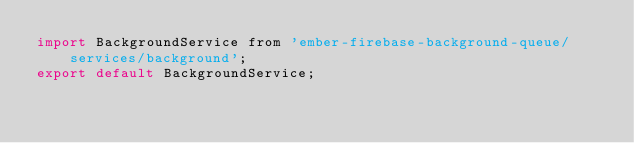Convert code to text. <code><loc_0><loc_0><loc_500><loc_500><_JavaScript_>import BackgroundService from 'ember-firebase-background-queue/services/background';
export default BackgroundService;</code> 